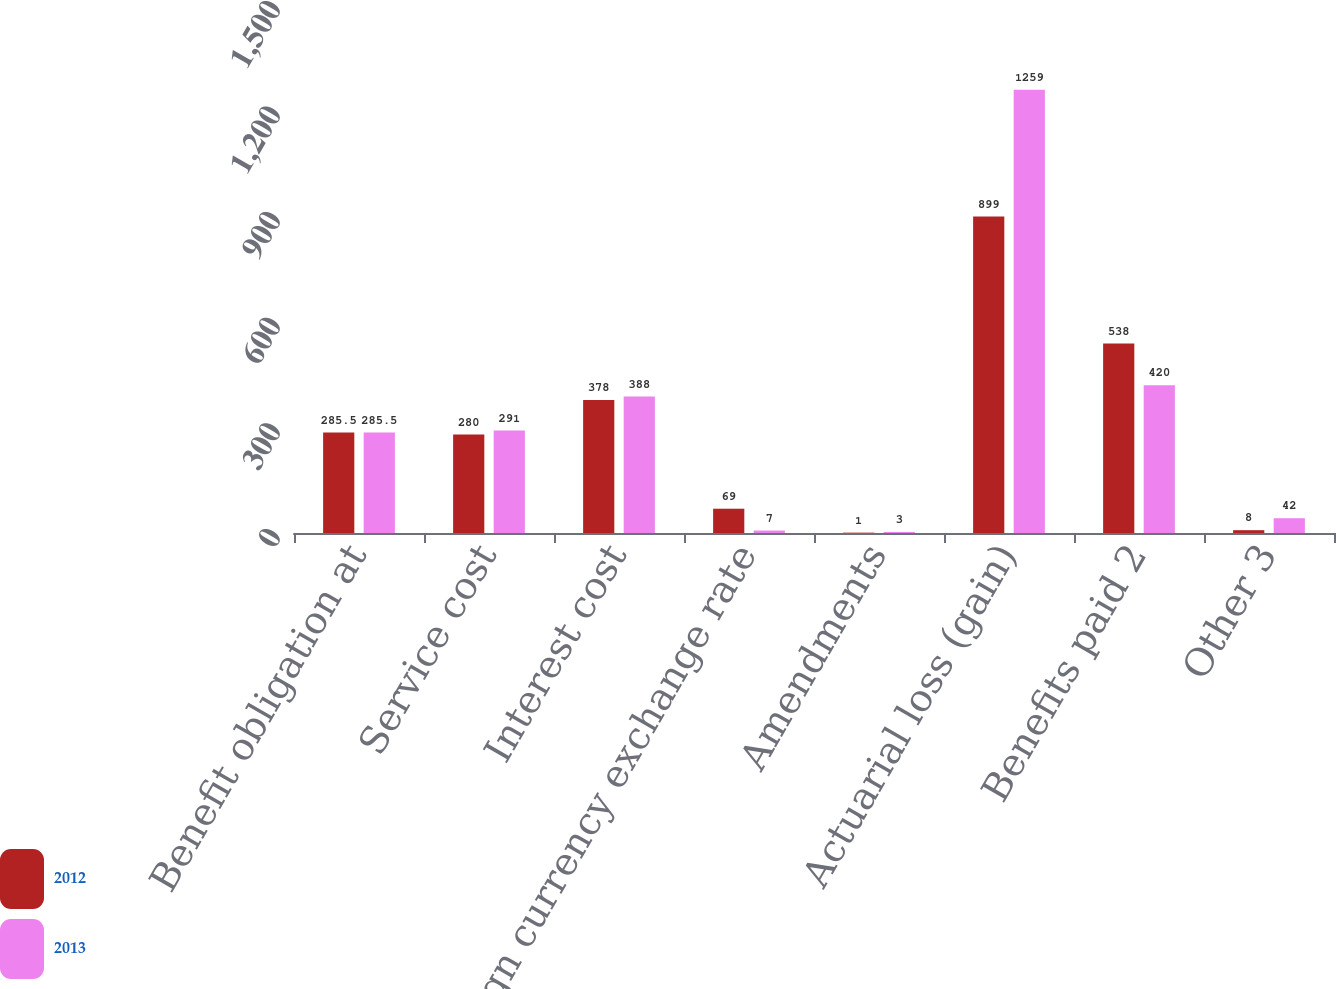Convert chart. <chart><loc_0><loc_0><loc_500><loc_500><stacked_bar_chart><ecel><fcel>Benefit obligation at<fcel>Service cost<fcel>Interest cost<fcel>Foreign currency exchange rate<fcel>Amendments<fcel>Actuarial loss (gain)<fcel>Benefits paid 2<fcel>Other 3<nl><fcel>2012<fcel>285.5<fcel>280<fcel>378<fcel>69<fcel>1<fcel>899<fcel>538<fcel>8<nl><fcel>2013<fcel>285.5<fcel>291<fcel>388<fcel>7<fcel>3<fcel>1259<fcel>420<fcel>42<nl></chart> 